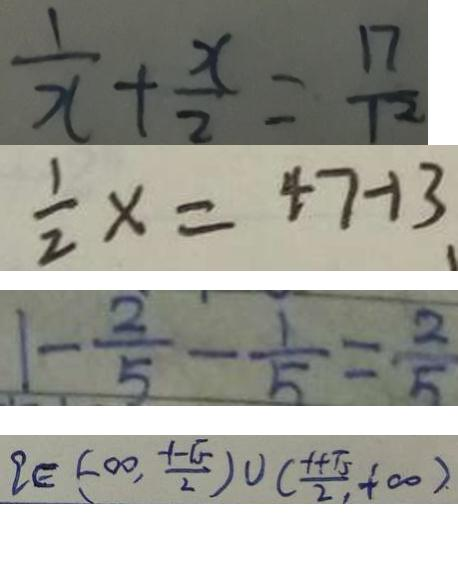Convert formula to latex. <formula><loc_0><loc_0><loc_500><loc_500>\frac { 1 } { x } + \frac { x } { 2 } = \frac { 1 7 } { 1 2 } 
 \frac { 1 } { 2 } x = 4 7 - 1 3 
 1 - \frac { 2 } { 5 } - \frac { 1 } { 5 } = \frac { 2 } { 5 } 
 q \in ( - \infty , \frac { - 1 - \sqrt { 5 } } { 2 } ) \cup ( \frac { - 1 + \sqrt { 5 } } { 2 } , + \infty )</formula> 